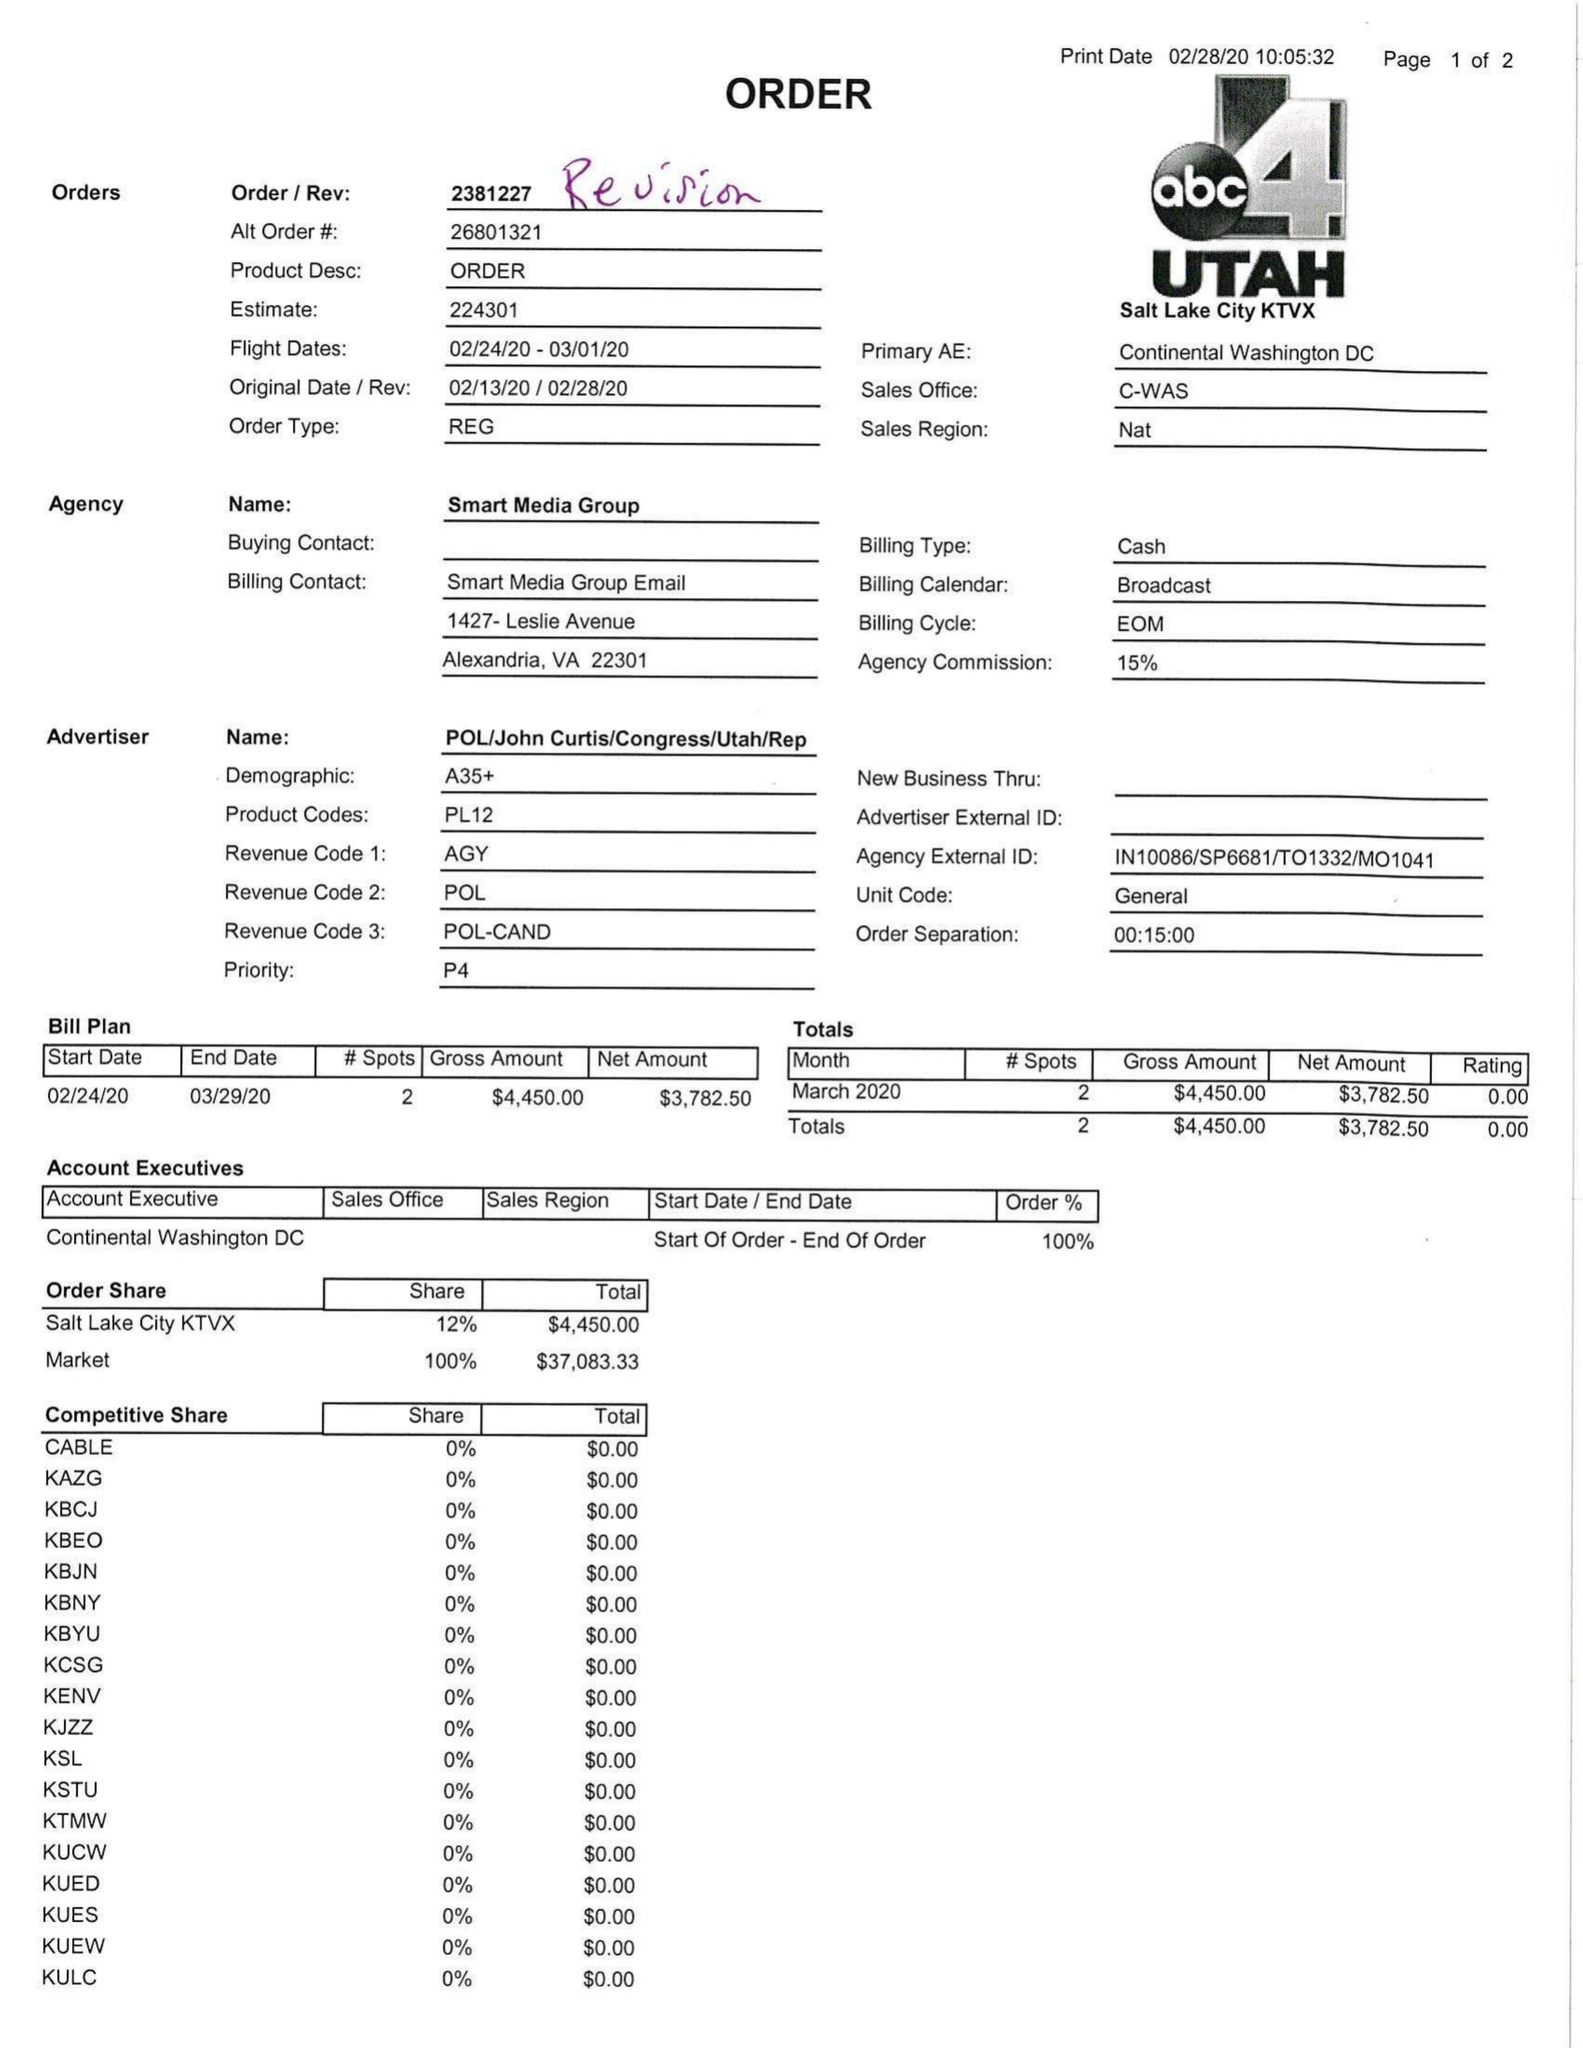What is the value for the flight_from?
Answer the question using a single word or phrase. 02/24/20 